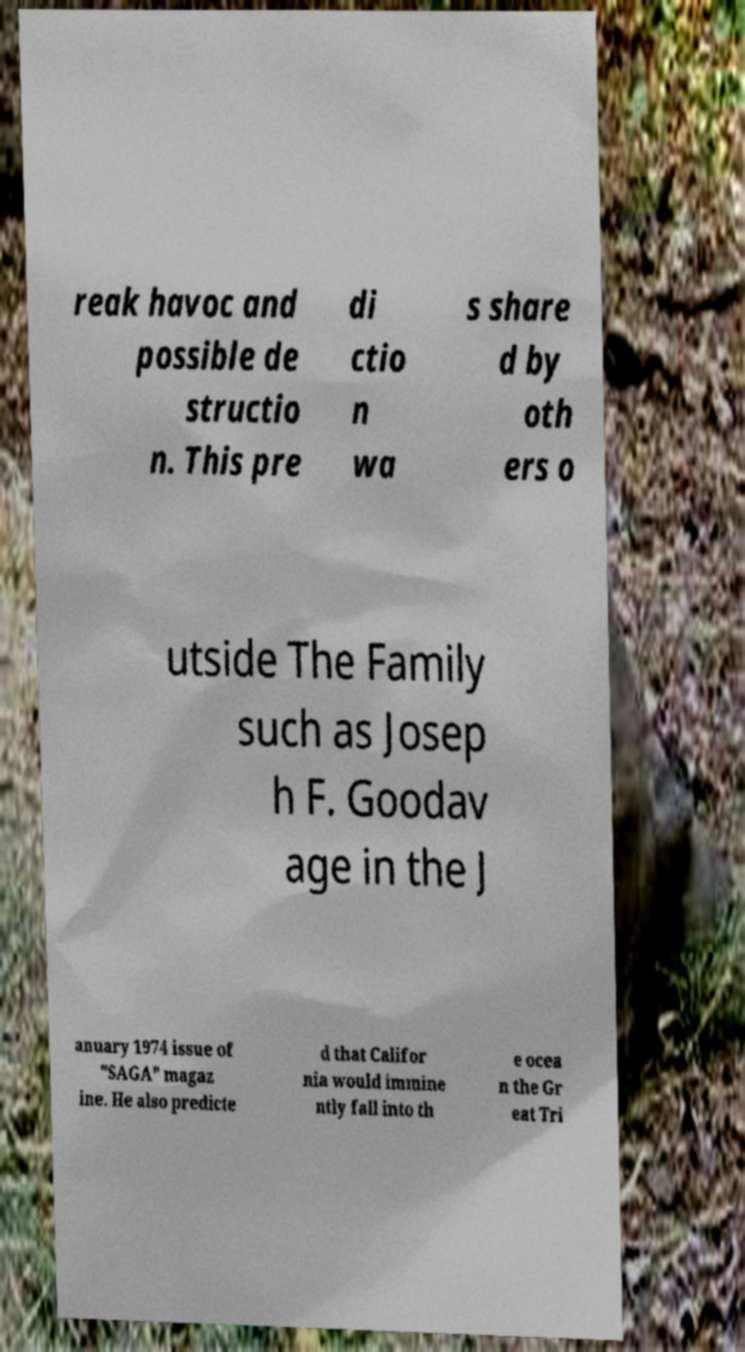I need the written content from this picture converted into text. Can you do that? reak havoc and possible de structio n. This pre di ctio n wa s share d by oth ers o utside The Family such as Josep h F. Goodav age in the J anuary 1974 issue of "SAGA" magaz ine. He also predicte d that Califor nia would immine ntly fall into th e ocea n the Gr eat Tri 